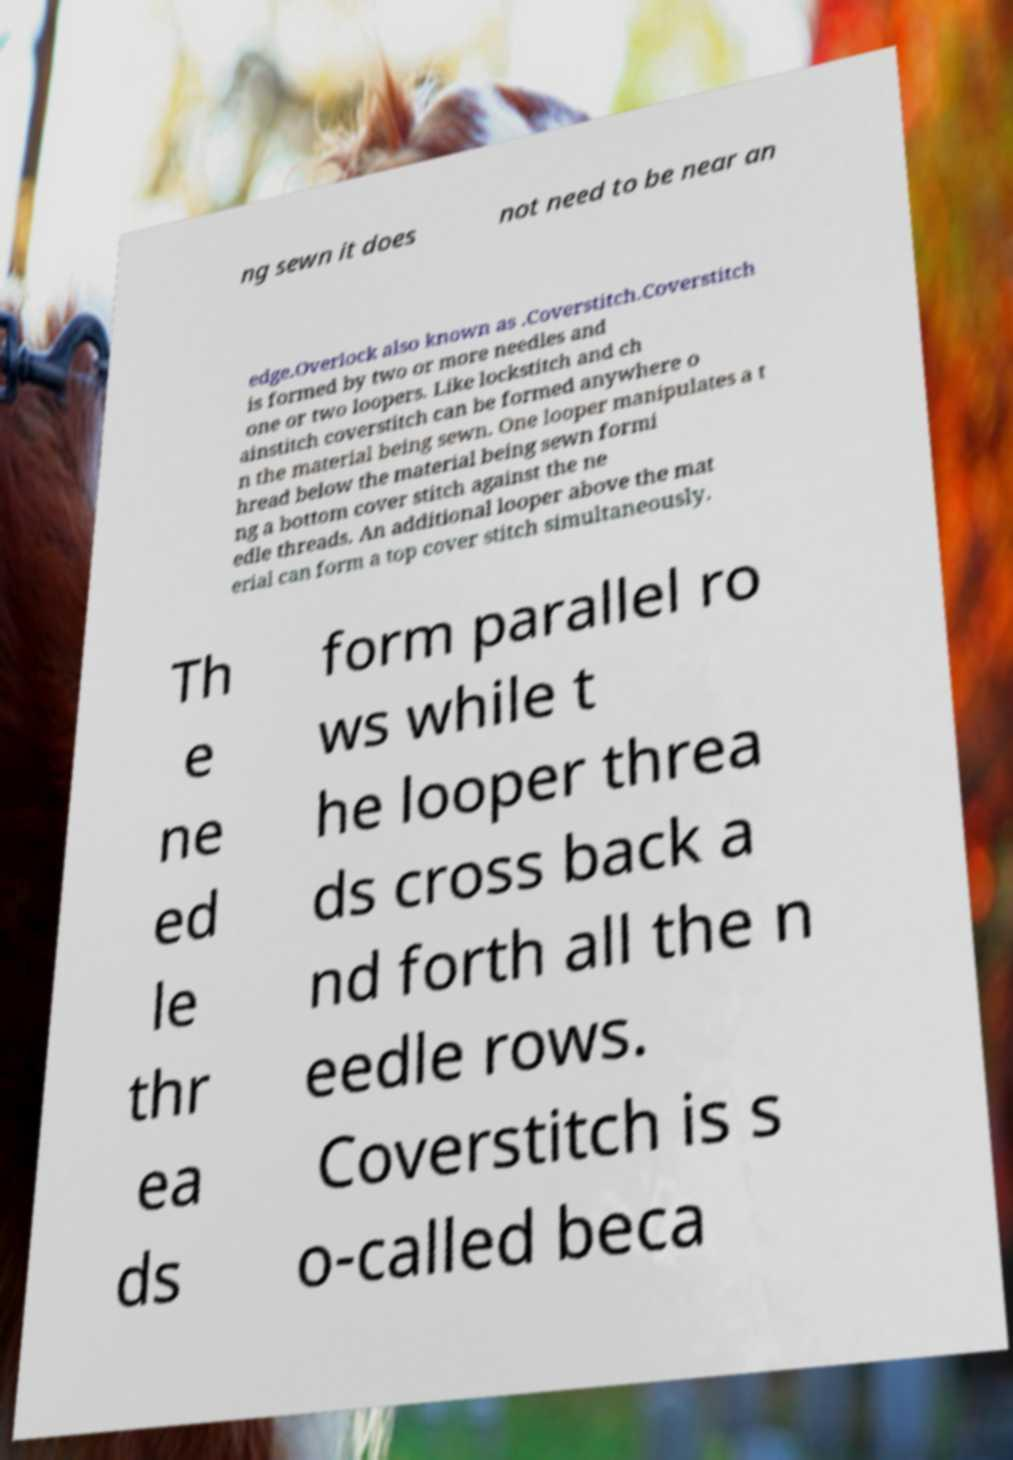Could you assist in decoding the text presented in this image and type it out clearly? ng sewn it does not need to be near an edge.Overlock also known as .Coverstitch.Coverstitch is formed by two or more needles and one or two loopers. Like lockstitch and ch ainstitch coverstitch can be formed anywhere o n the material being sewn. One looper manipulates a t hread below the material being sewn formi ng a bottom cover stitch against the ne edle threads. An additional looper above the mat erial can form a top cover stitch simultaneously. Th e ne ed le thr ea ds form parallel ro ws while t he looper threa ds cross back a nd forth all the n eedle rows. Coverstitch is s o-called beca 